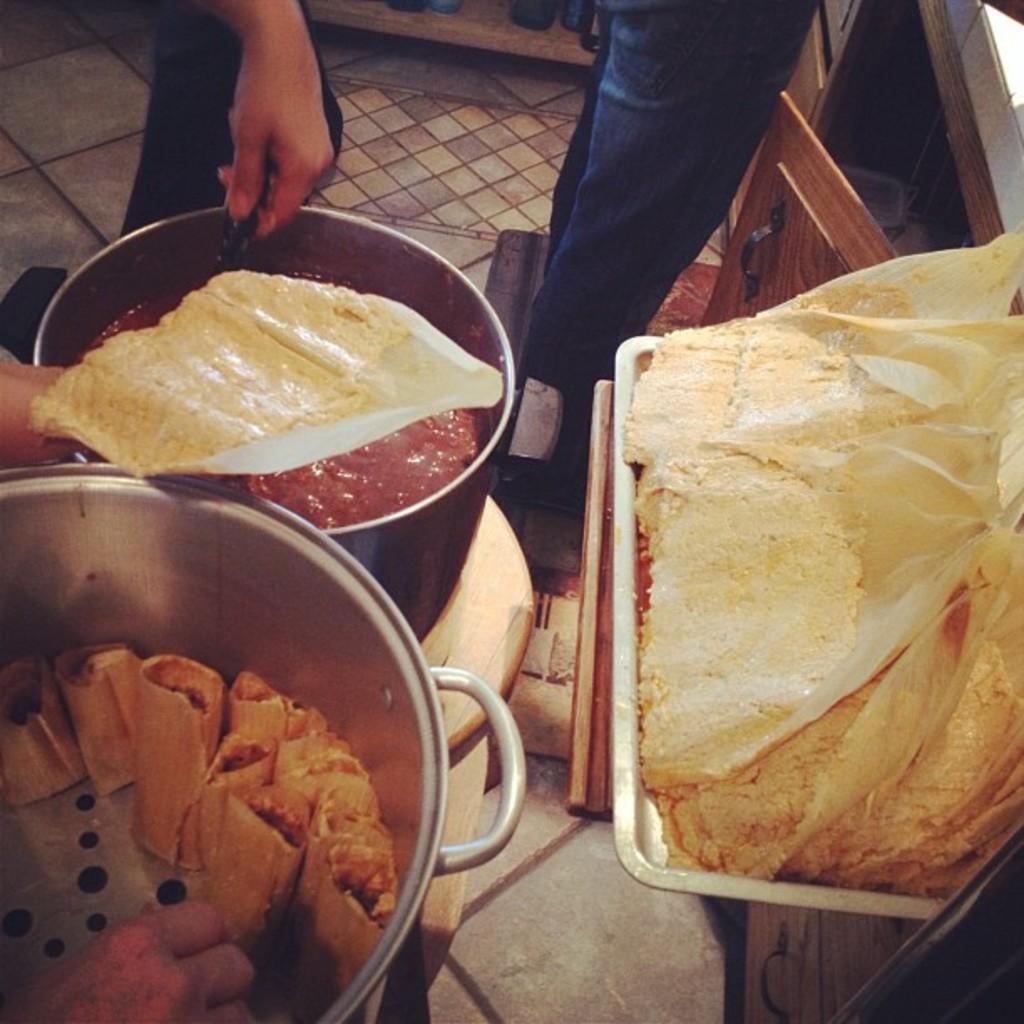Could you give a brief overview of what you see in this image? In this image I can see few utensils and in it I can see different types of food. I can also see cupboard and here I can see hands of a person is holding yellow color thing. I can also see one more person is standing over here. 